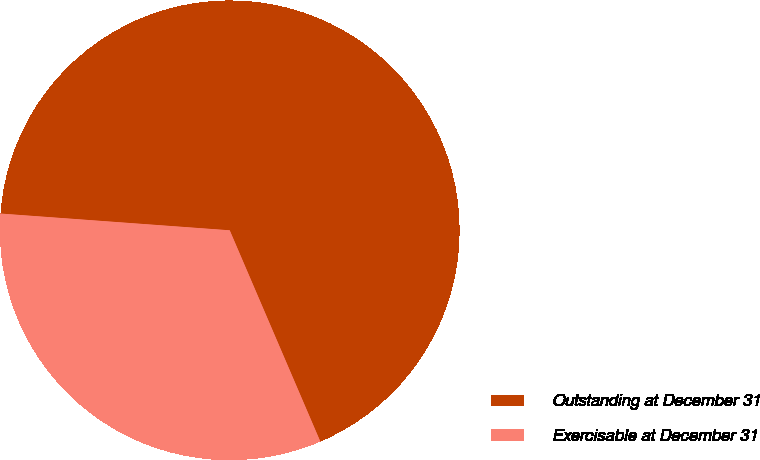Convert chart. <chart><loc_0><loc_0><loc_500><loc_500><pie_chart><fcel>Outstanding at December 31<fcel>Exercisable at December 31<nl><fcel>67.39%<fcel>32.61%<nl></chart> 